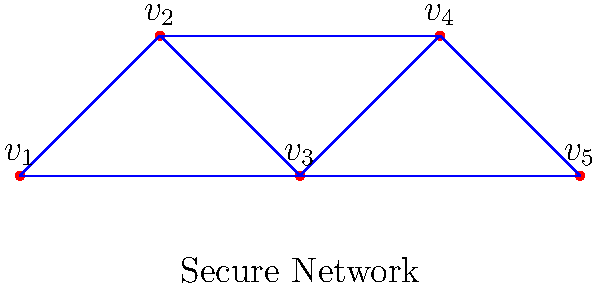An organization's secure communication network is represented by the graph above. Each vertex represents a communication node, and each edge represents a secure connection between nodes. As an ethical hacker, you're tasked with finding the minimum number of connections (edges) that need to be compromised to isolate at least one node from the rest of the network. What is this minimum number? To solve this problem, we need to understand the concept of edge connectivity in graph theory. The edge connectivity of a graph is the minimum number of edges that need to be removed to disconnect the graph.

Let's approach this step-by-step:

1) First, observe that the graph is connected, meaning there's a path between any two vertices.

2) To isolate a node, we need to remove all edges connected to it. The node with the least number of connections would require the least effort to isolate.

3) Counting the edges for each vertex:
   $v_1$: 2 edges
   $v_2$: 3 edges
   $v_3$: 3 edges
   $v_4$: 2 edges
   $v_5$: 2 edges

4) The vertices $v_1$, $v_4$, and $v_5$ each have only 2 connections.

5) Therefore, the minimum number of edges that need to be removed to isolate a vertex is 2.

6) Removing these 2 edges would disconnect either $v_1$, $v_4$, or $v_5$ from the rest of the network.

This approach ensures that at least one node (communication point) is isolated from the network, potentially compromising the secure communication system with minimal effort.
Answer: 2 edges 